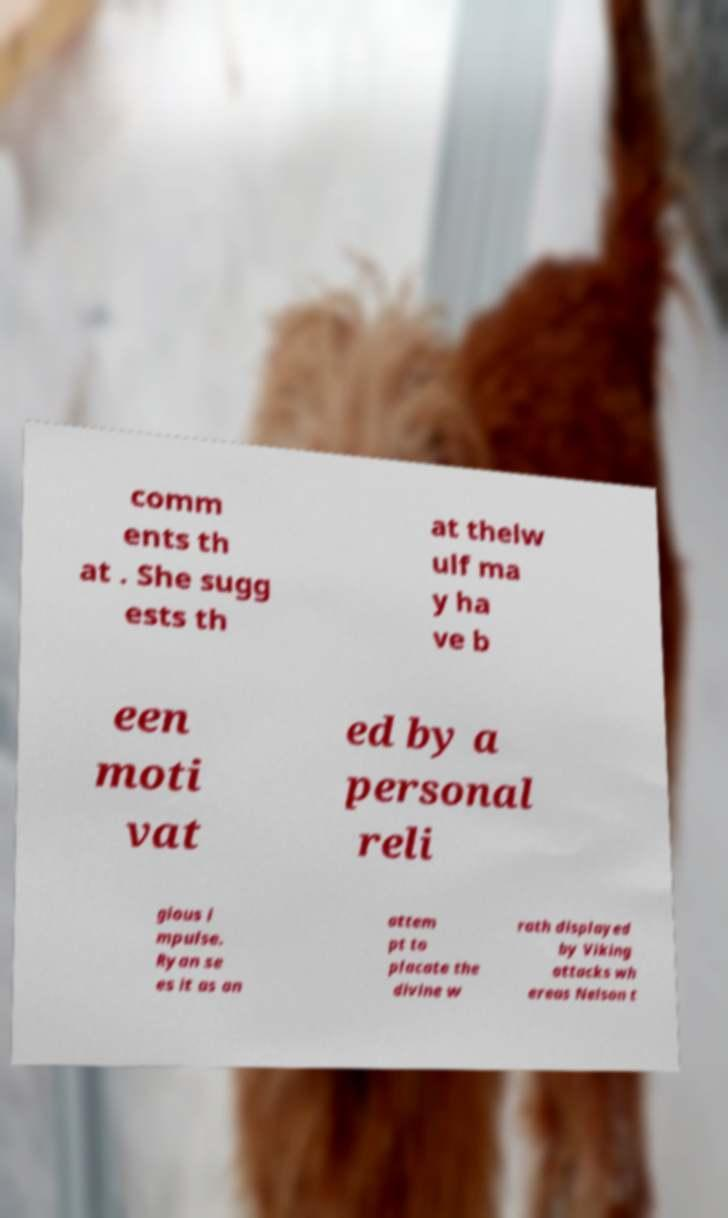I need the written content from this picture converted into text. Can you do that? comm ents th at . She sugg ests th at thelw ulf ma y ha ve b een moti vat ed by a personal reli gious i mpulse. Ryan se es it as an attem pt to placate the divine w rath displayed by Viking attacks wh ereas Nelson t 